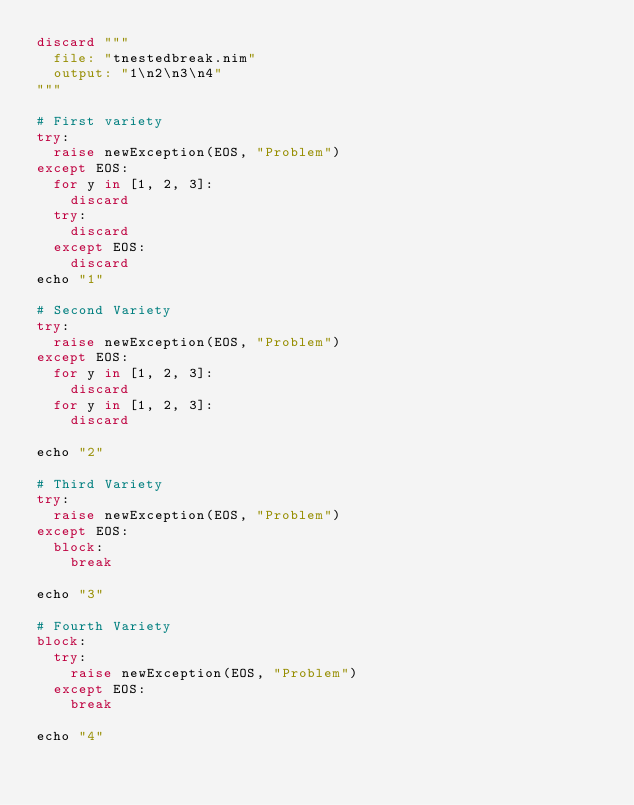<code> <loc_0><loc_0><loc_500><loc_500><_Nim_>discard """
  file: "tnestedbreak.nim"
  output: "1\n2\n3\n4"
"""

# First variety
try:
  raise newException(EOS, "Problem")
except EOS:
  for y in [1, 2, 3]:
    discard
  try:
    discard
  except EOS:
    discard
echo "1"

# Second Variety
try:
  raise newException(EOS, "Problem")
except EOS:
  for y in [1, 2, 3]:
    discard
  for y in [1, 2, 3]:
    discard

echo "2"

# Third Variety
try:
  raise newException(EOS, "Problem")
except EOS:
  block:
    break

echo "3"

# Fourth Variety
block:
  try:
    raise newException(EOS, "Problem")
  except EOS:
    break

echo "4"</code> 